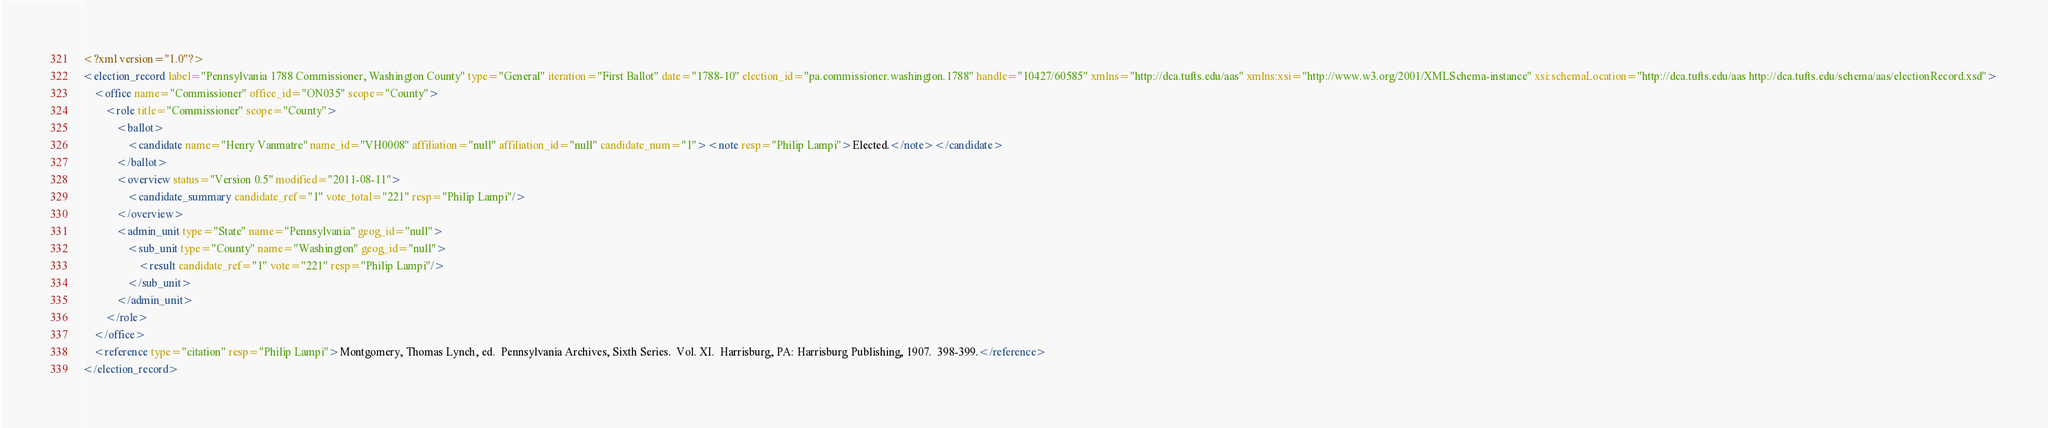Convert code to text. <code><loc_0><loc_0><loc_500><loc_500><_XML_><?xml version="1.0"?>
<election_record label="Pennsylvania 1788 Commissioner, Washington County" type="General" iteration="First Ballot" date="1788-10" election_id="pa.commissioner.washington.1788" handle="10427/60585" xmlns="http://dca.tufts.edu/aas" xmlns:xsi="http://www.w3.org/2001/XMLSchema-instance" xsi:schemaLocation="http://dca.tufts.edu/aas http://dca.tufts.edu/schema/aas/electionRecord.xsd">
    <office name="Commissioner" office_id="ON035" scope="County">
        <role title="Commissioner" scope="County">
            <ballot>
                <candidate name="Henry Vanmatre" name_id="VH0008" affiliation="null" affiliation_id="null" candidate_num="1"><note resp="Philip Lampi">Elected.</note></candidate>
            </ballot>
            <overview status="Version 0.5" modified="2011-08-11">
                <candidate_summary candidate_ref="1" vote_total="221" resp="Philip Lampi"/>
            </overview>
            <admin_unit type="State" name="Pennsylvania" geog_id="null">
                <sub_unit type="County" name="Washington" geog_id="null">
                    <result candidate_ref="1" vote="221" resp="Philip Lampi"/>
                </sub_unit>
            </admin_unit>
        </role>
    </office>
    <reference type="citation" resp="Philip Lampi">Montgomery, Thomas Lynch, ed.  Pennsylvania Archives, Sixth Series.  Vol. XI.  Harrisburg, PA: Harrisburg Publishing, 1907.  398-399.</reference>
</election_record>
</code> 